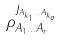Convert formula to latex. <formula><loc_0><loc_0><loc_500><loc_500>\rho _ { A _ { 1 } \dots A _ { r } } ^ { J _ { A _ { k _ { 1 } } \dots A _ { k _ { o } } } }</formula> 